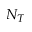Convert formula to latex. <formula><loc_0><loc_0><loc_500><loc_500>N _ { T }</formula> 